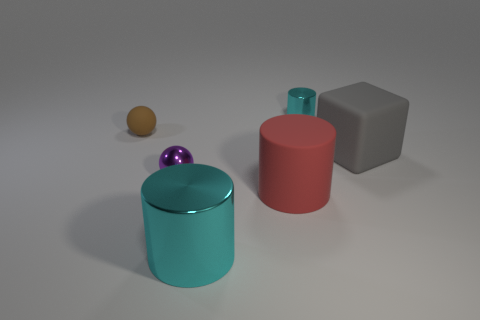There is a tiny metal object that is in front of the large matte cube; is it the same shape as the red thing?
Your answer should be compact. No. Are there more large red rubber cylinders that are right of the big matte block than small purple rubber things?
Keep it short and to the point. No. What number of rubber cylinders have the same size as the red matte thing?
Give a very brief answer. 0. The metal thing that is the same color as the small shiny cylinder is what size?
Ensure brevity in your answer.  Large. How many things are either gray rubber balls or cyan cylinders that are to the left of the tiny cylinder?
Your response must be concise. 1. What color is the thing that is both left of the big gray object and on the right side of the red object?
Keep it short and to the point. Cyan. Do the gray matte cube and the purple metallic ball have the same size?
Your answer should be very brief. No. There is a tiny metallic object that is behind the tiny brown rubber ball; what is its color?
Give a very brief answer. Cyan. Is there a small object of the same color as the large block?
Your answer should be very brief. No. There is a shiny cylinder that is the same size as the brown ball; what color is it?
Offer a very short reply. Cyan. 